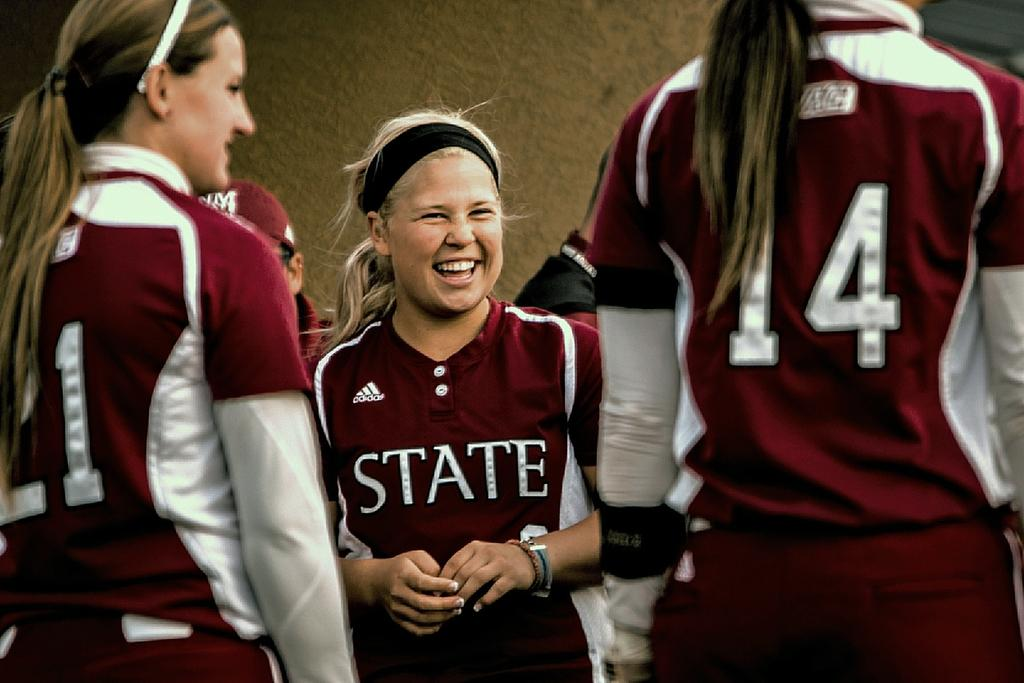<image>
Provide a brief description of the given image. A woman wearing an Adidas shirt that says State on the front. 